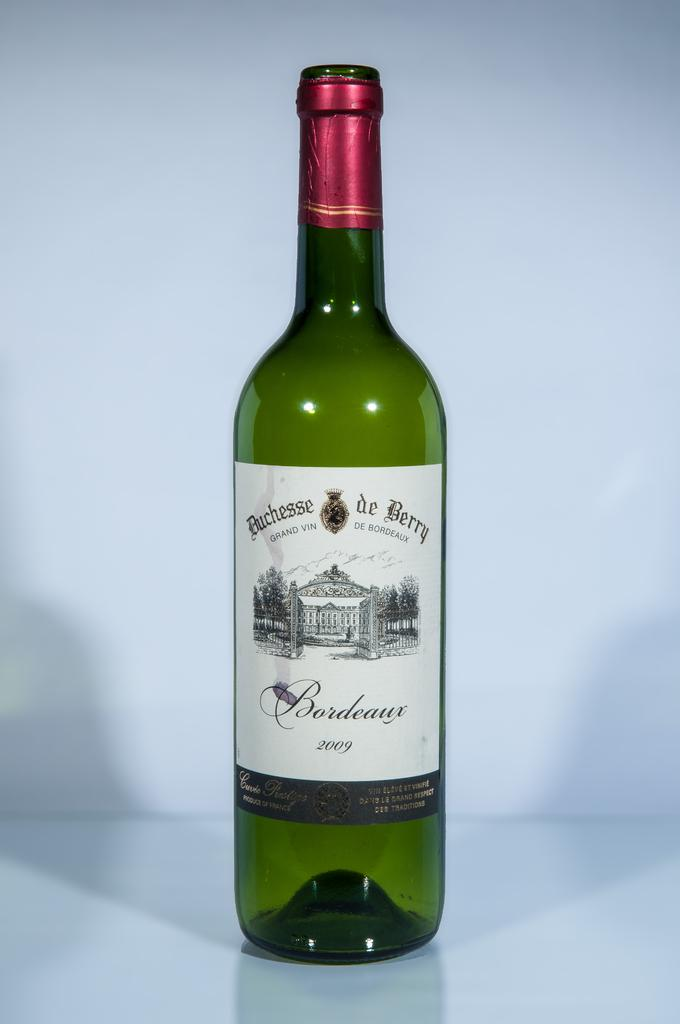Provide a one-sentence caption for the provided image. Green bottle of Buchessede Berry with a red cover. 